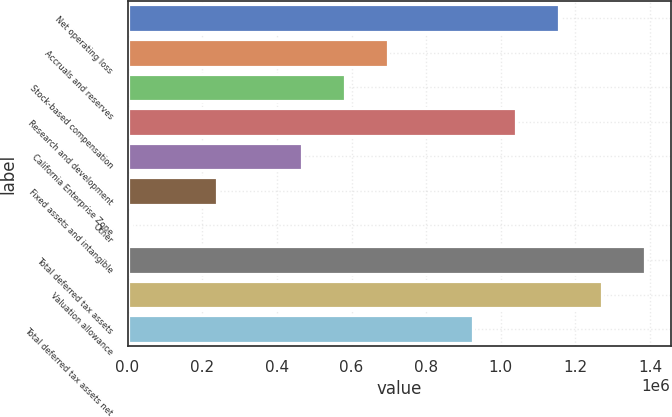Convert chart to OTSL. <chart><loc_0><loc_0><loc_500><loc_500><bar_chart><fcel>Net operating loss<fcel>Accruals and reserves<fcel>Stock-based compensation<fcel>Research and development<fcel>California Enterprise Zone<fcel>Fixed assets and intangible<fcel>Other<fcel>Total deferred tax assets<fcel>Valuation allowance<fcel>Total deferred tax assets net<nl><fcel>1.15607e+06<fcel>697182<fcel>582458<fcel>1.04135e+06<fcel>467735<fcel>238289<fcel>8843<fcel>1.38552e+06<fcel>1.2708e+06<fcel>926628<nl></chart> 